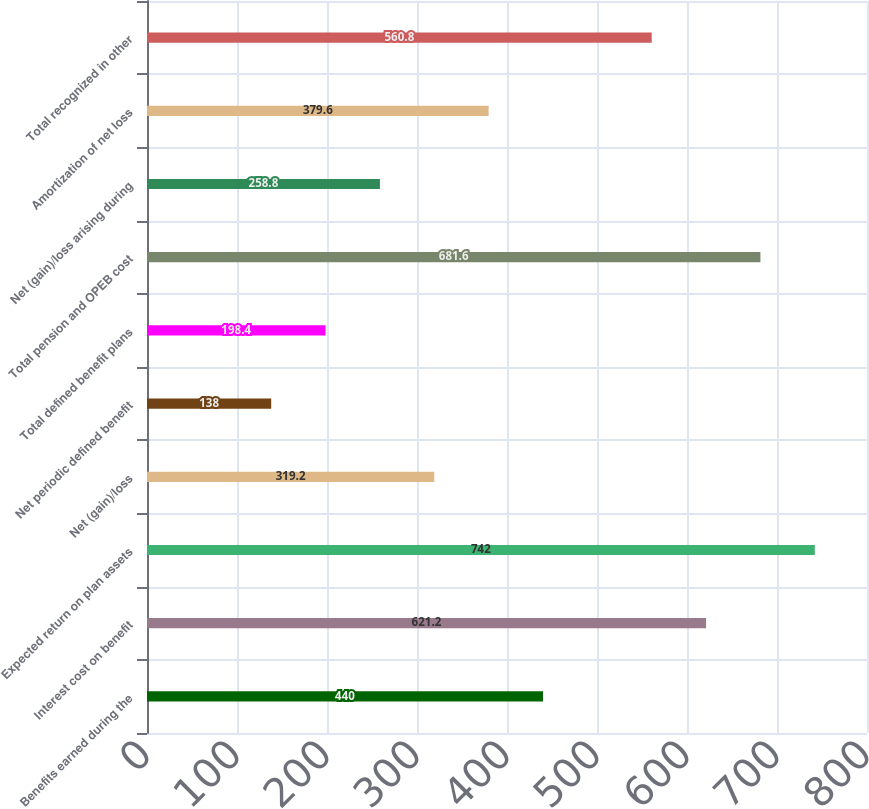<chart> <loc_0><loc_0><loc_500><loc_500><bar_chart><fcel>Benefits earned during the<fcel>Interest cost on benefit<fcel>Expected return on plan assets<fcel>Net (gain)/loss<fcel>Net periodic defined benefit<fcel>Total defined benefit plans<fcel>Total pension and OPEB cost<fcel>Net (gain)/loss arising during<fcel>Amortization of net loss<fcel>Total recognized in other<nl><fcel>440<fcel>621.2<fcel>742<fcel>319.2<fcel>138<fcel>198.4<fcel>681.6<fcel>258.8<fcel>379.6<fcel>560.8<nl></chart> 